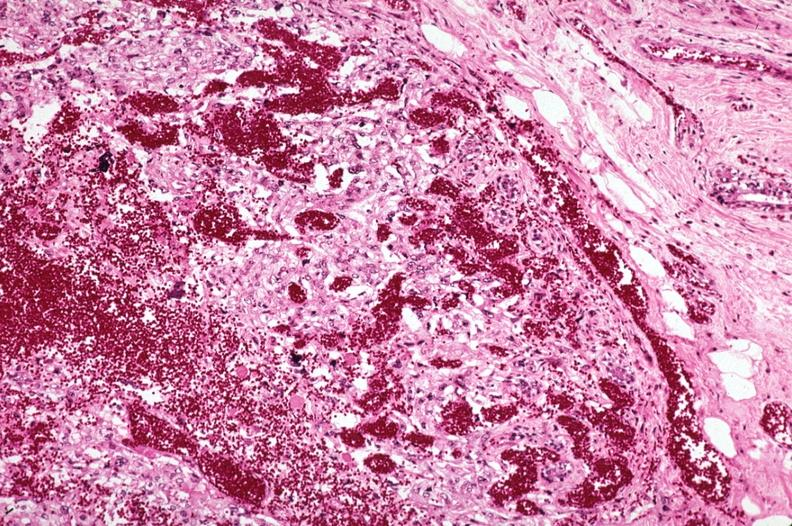s metastatic carcinoma present?
Answer the question using a single word or phrase. Yes 